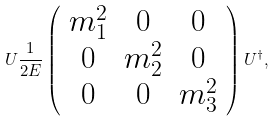<formula> <loc_0><loc_0><loc_500><loc_500>U \frac { 1 } { 2 E } \left ( \begin{array} { c c c } m _ { 1 } ^ { 2 } & 0 & 0 \\ 0 & m _ { 2 } ^ { 2 } & 0 \\ 0 & 0 & m _ { 3 } ^ { 2 } \\ \end{array} \right ) U ^ { \dag } ,</formula> 